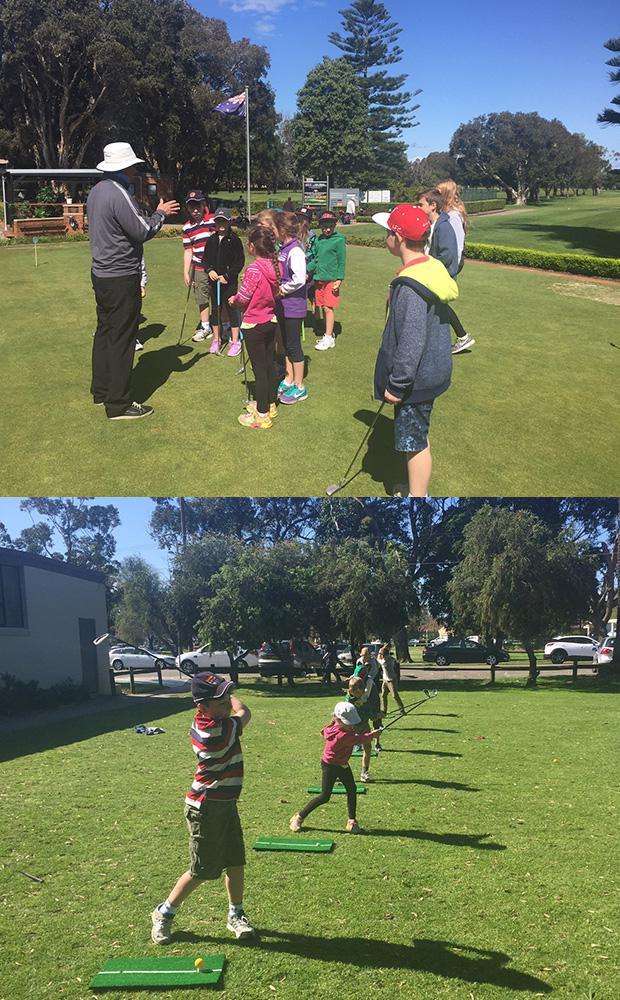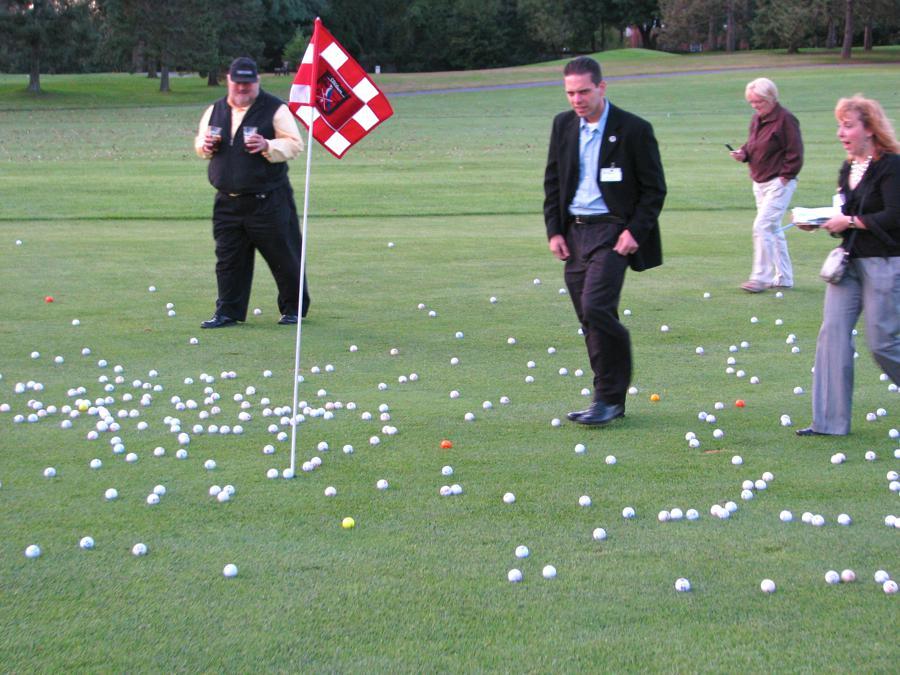The first image is the image on the left, the second image is the image on the right. For the images shown, is this caption "A red and white checked flag sits on the golf course in one of the images." true? Answer yes or no. Yes. The first image is the image on the left, the second image is the image on the right. Examine the images to the left and right. Is the description "An image shows a group of people on a golf green with a red checkered flag on a pole." accurate? Answer yes or no. Yes. 